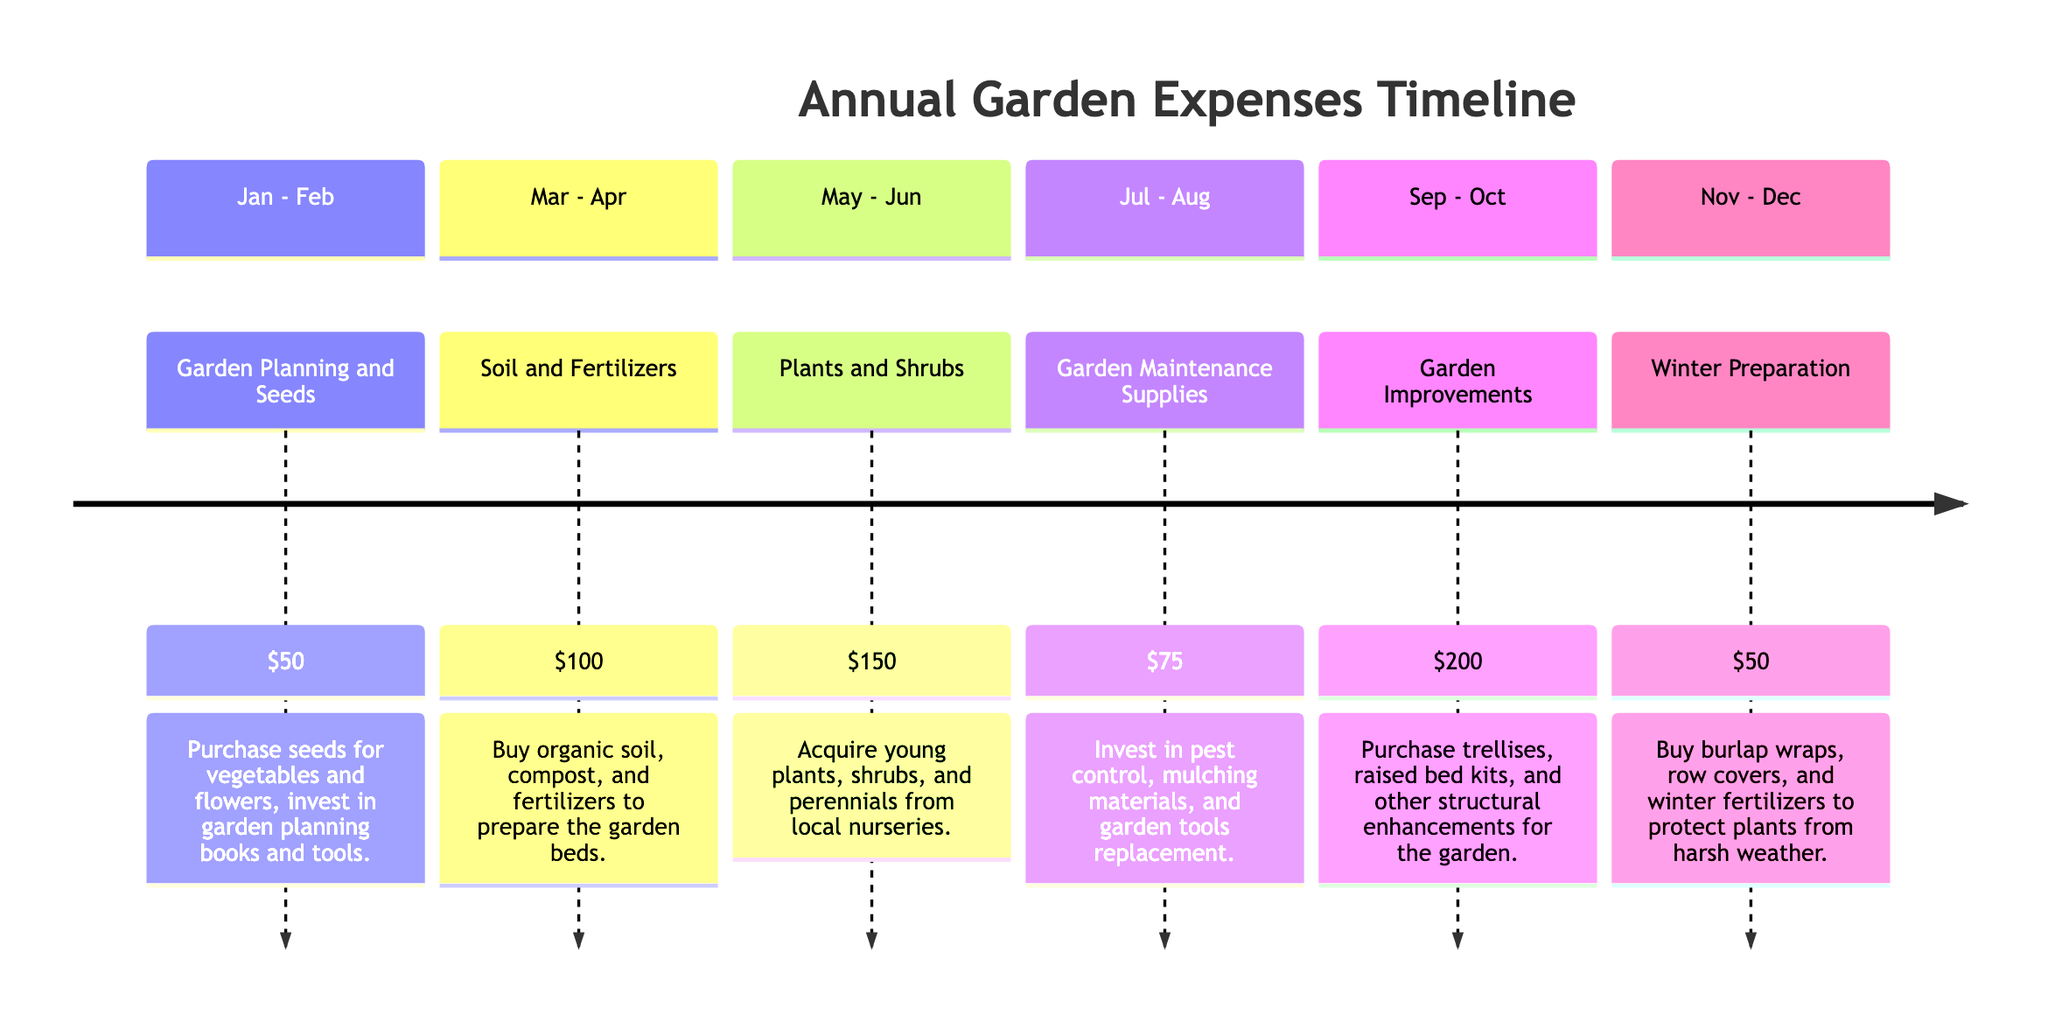What is the total amount spent from May to June? To find the total amount spent during May to June, I need to look at the expense listed in that section, which is $150 for "Plants and Shrubs." Since there are no other expenses for that time frame, the total amount is simply $150.
Answer: $150 What supplies are purchased in March to April? The item listed for March to April is "Soil and Fertilizers," which includes organic soil, compost, and fertilizers for preparing the garden beds. Therefore, the supplies purchased are soil and fertilizers.
Answer: Soil and Fertilizers Which time period has the highest expense? By examining each time period and their corresponding expenses, the highest expense is found in the September to October section with "Garden Improvements" at $200.
Answer: $200 How much is spent on Winter Preparation? Looking at the November to December section, the expense listed for "Winter Preparation" is $50. Since that's the only expense for that time frame, the total amount spent is $50.
Answer: $50 What is the total annual expense for gardening? To find the total annual expense, I will add up all the individual amounts: $50 (Jan-Feb) + $100 (Mar-Apr) + $150 (May-Jun) + $75 (Jul-Aug) + $200 (Sep-Oct) + $50 (Nov-Dec). This totals to $625.
Answer: $625 How many sections are there in the timeline? The timeline is divided into six sections: January - February, March - April, May - June, July - August, September - October, and November - December. Therefore, there are 6 sections total.
Answer: 6 What types of improvements are included in the September to October expense? The September to October expense is categorized as "Garden Improvements," which includes purchasing trellises, raised bed kits, and other structural enhancements for the garden.
Answer: Trellises, raised bed kits Which months focus on garden maintenance supplies? The months focusing on garden maintenance supplies are July and August, where the specific expense listed is "$75" for maintaining the garden.
Answer: July - August What is the main purpose of the expenses in November - December? The main purpose of the expenses in November - December is for "Winter Preparation," which involves buying burlap wraps, row covers, and winter fertilizers to protect plants from weather.
Answer: Winter Preparation 